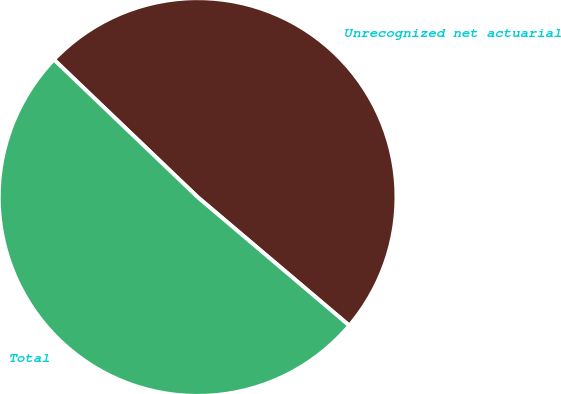Convert chart. <chart><loc_0><loc_0><loc_500><loc_500><pie_chart><fcel>Unrecognized net actuarial<fcel>Total<nl><fcel>49.04%<fcel>50.96%<nl></chart> 